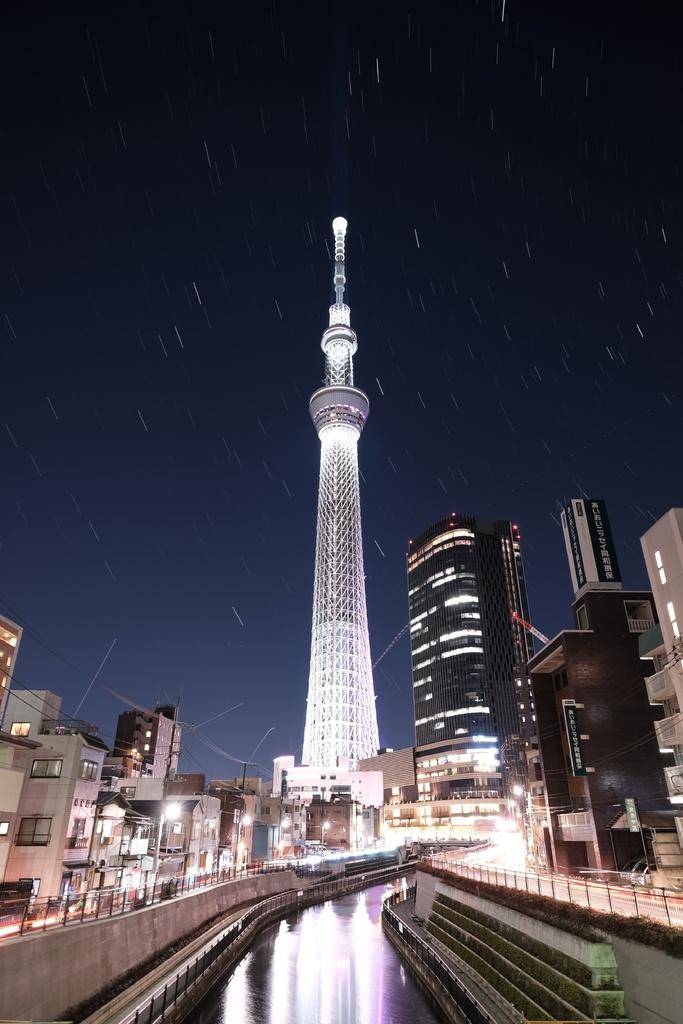What is the primary element visible in the image? There is water in the image. What other objects can be seen in the image? There are lights, poles, buildings, and a tower in the image. How would you describe the lighting conditions in the image? The background of the image is dark. Where is the fire hydrant located in the image? There is no fire hydrant present in the image. What type of meat is being grilled in the image? There is no meat or grilling activity present in the image. 